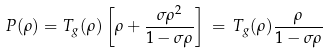<formula> <loc_0><loc_0><loc_500><loc_500>P ( \rho ) = T _ { g } ( \rho ) \left [ \rho + \frac { \sigma \rho ^ { 2 } } { 1 - \sigma \rho } \right ] \, = \, T _ { g } ( \rho ) \frac { \rho } { 1 - \sigma \rho }</formula> 